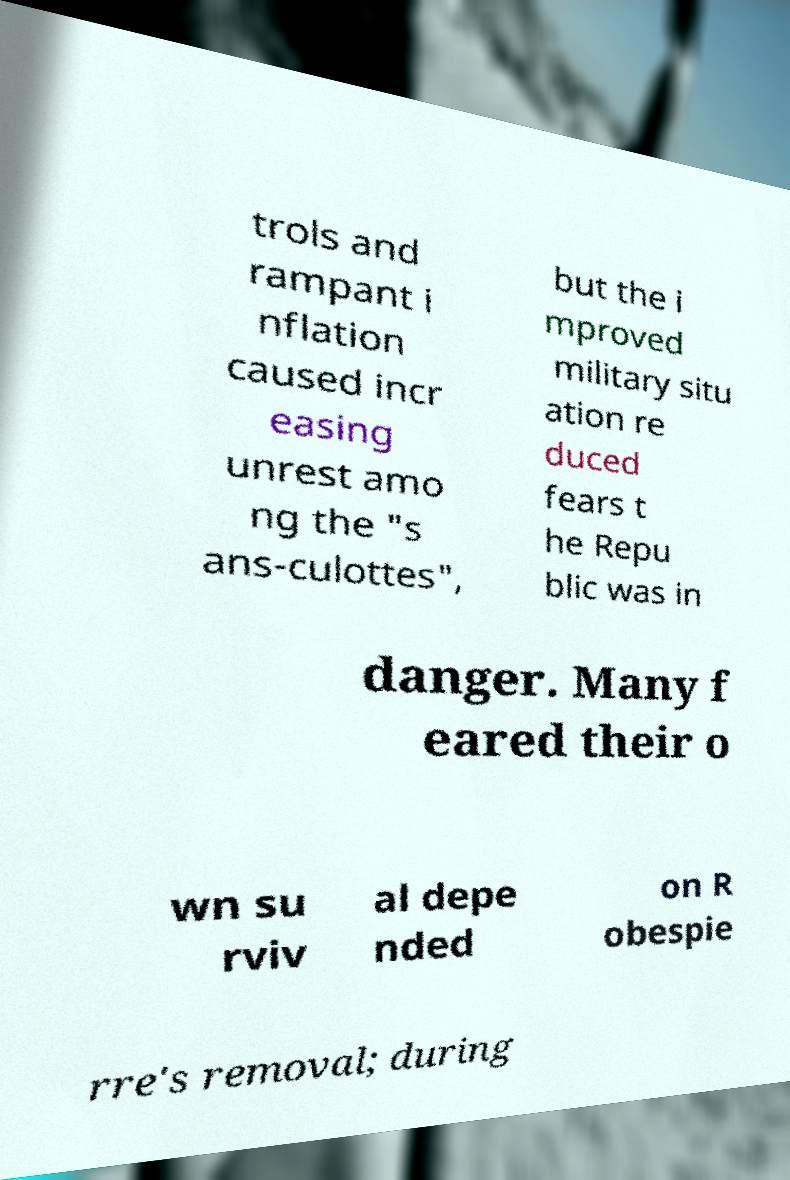Please identify and transcribe the text found in this image. trols and rampant i nflation caused incr easing unrest amo ng the "s ans-culottes", but the i mproved military situ ation re duced fears t he Repu blic was in danger. Many f eared their o wn su rviv al depe nded on R obespie rre's removal; during 